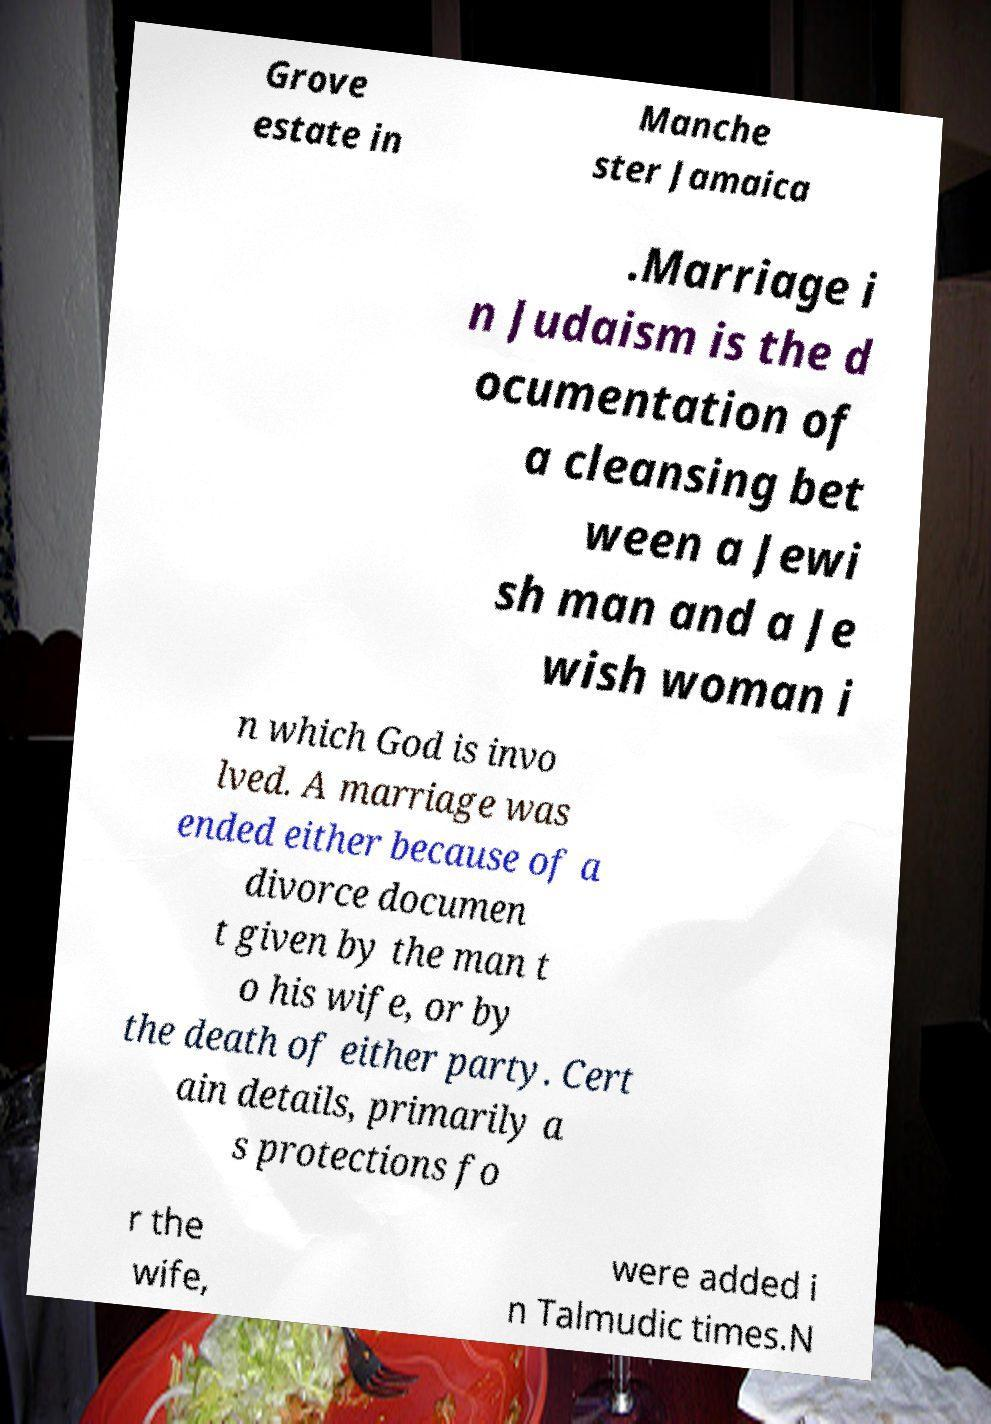I need the written content from this picture converted into text. Can you do that? Grove estate in Manche ster Jamaica .Marriage i n Judaism is the d ocumentation of a cleansing bet ween a Jewi sh man and a Je wish woman i n which God is invo lved. A marriage was ended either because of a divorce documen t given by the man t o his wife, or by the death of either party. Cert ain details, primarily a s protections fo r the wife, were added i n Talmudic times.N 